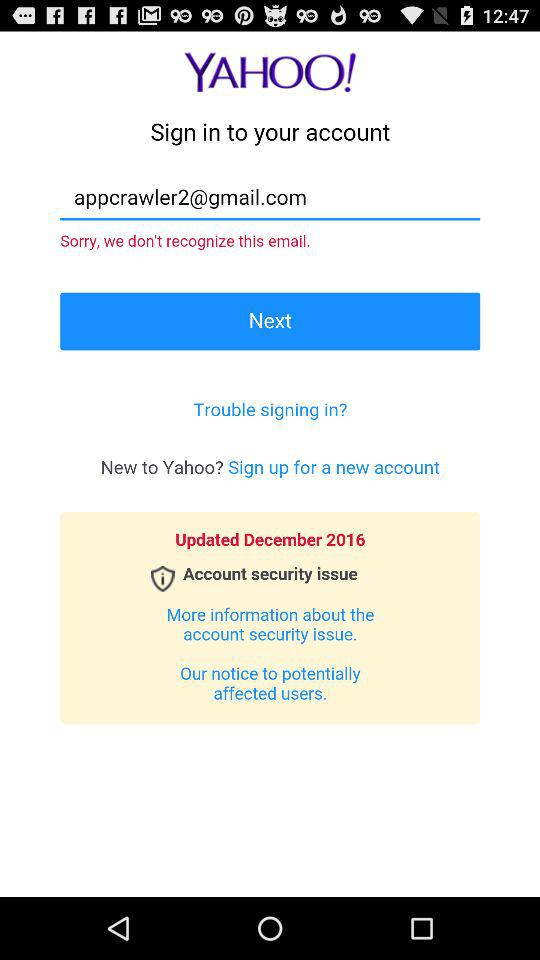When was it updated? It was last updated in December 2016. 